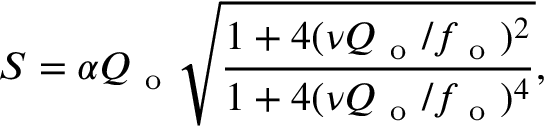<formula> <loc_0><loc_0><loc_500><loc_500>S = \alpha Q _ { o } \sqrt { \frac { 1 + 4 ( \nu Q _ { o } / f _ { o } ) ^ { 2 } } { 1 + 4 ( \nu Q _ { o } / f _ { o } ) ^ { 4 } } } ,</formula> 